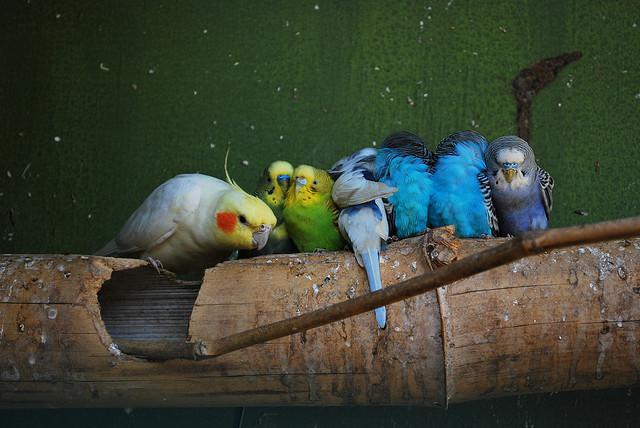What type of bird is the one on the far left? parrot 